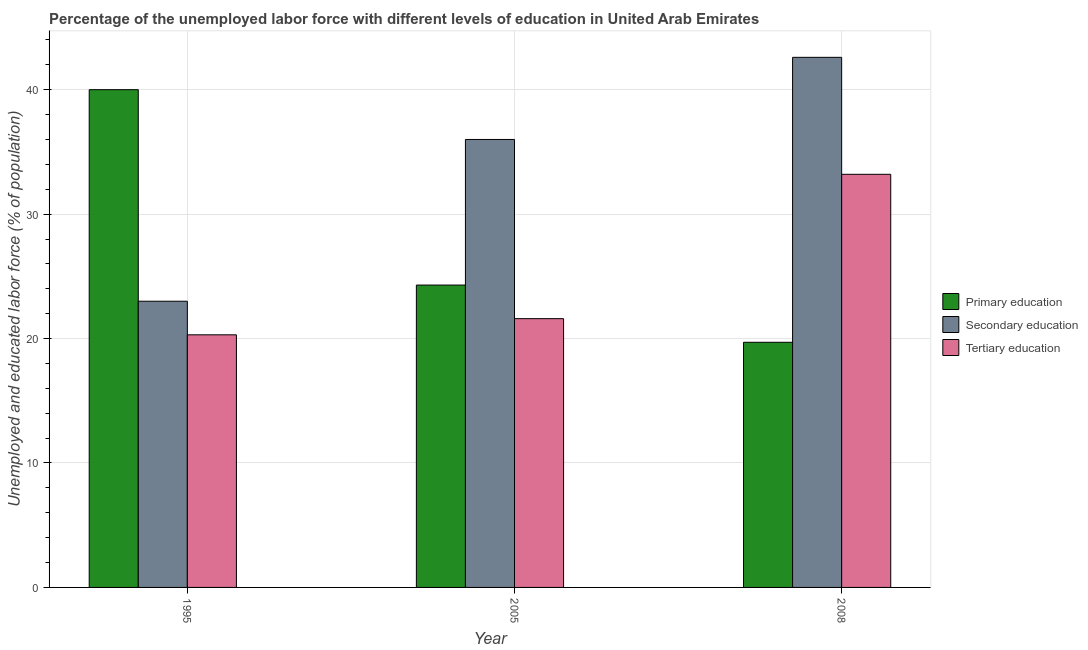Are the number of bars per tick equal to the number of legend labels?
Offer a very short reply. Yes. Are the number of bars on each tick of the X-axis equal?
Your answer should be compact. Yes. What is the label of the 1st group of bars from the left?
Provide a succinct answer. 1995. In how many cases, is the number of bars for a given year not equal to the number of legend labels?
Offer a terse response. 0. What is the percentage of labor force who received tertiary education in 2005?
Keep it short and to the point. 21.6. Across all years, what is the maximum percentage of labor force who received secondary education?
Provide a short and direct response. 42.6. In which year was the percentage of labor force who received tertiary education maximum?
Offer a terse response. 2008. In which year was the percentage of labor force who received tertiary education minimum?
Your answer should be compact. 1995. What is the difference between the percentage of labor force who received secondary education in 1995 and that in 2008?
Provide a short and direct response. -19.6. What is the difference between the percentage of labor force who received primary education in 2008 and the percentage of labor force who received secondary education in 1995?
Make the answer very short. -20.3. What is the average percentage of labor force who received primary education per year?
Keep it short and to the point. 28. In how many years, is the percentage of labor force who received tertiary education greater than 36 %?
Your answer should be very brief. 0. What is the ratio of the percentage of labor force who received secondary education in 1995 to that in 2005?
Ensure brevity in your answer.  0.64. Is the difference between the percentage of labor force who received tertiary education in 1995 and 2008 greater than the difference between the percentage of labor force who received secondary education in 1995 and 2008?
Ensure brevity in your answer.  No. What is the difference between the highest and the second highest percentage of labor force who received tertiary education?
Make the answer very short. 11.6. What is the difference between the highest and the lowest percentage of labor force who received tertiary education?
Offer a terse response. 12.9. What does the 2nd bar from the left in 2005 represents?
Offer a very short reply. Secondary education. What does the 1st bar from the right in 2005 represents?
Offer a very short reply. Tertiary education. Is it the case that in every year, the sum of the percentage of labor force who received primary education and percentage of labor force who received secondary education is greater than the percentage of labor force who received tertiary education?
Your response must be concise. Yes. Are all the bars in the graph horizontal?
Give a very brief answer. No. How many years are there in the graph?
Make the answer very short. 3. Are the values on the major ticks of Y-axis written in scientific E-notation?
Make the answer very short. No. Does the graph contain any zero values?
Provide a succinct answer. No. Does the graph contain grids?
Your answer should be compact. Yes. How many legend labels are there?
Offer a terse response. 3. How are the legend labels stacked?
Give a very brief answer. Vertical. What is the title of the graph?
Give a very brief answer. Percentage of the unemployed labor force with different levels of education in United Arab Emirates. Does "Coal sources" appear as one of the legend labels in the graph?
Ensure brevity in your answer.  No. What is the label or title of the Y-axis?
Make the answer very short. Unemployed and educated labor force (% of population). What is the Unemployed and educated labor force (% of population) of Primary education in 1995?
Give a very brief answer. 40. What is the Unemployed and educated labor force (% of population) of Tertiary education in 1995?
Your answer should be compact. 20.3. What is the Unemployed and educated labor force (% of population) in Primary education in 2005?
Provide a succinct answer. 24.3. What is the Unemployed and educated labor force (% of population) of Tertiary education in 2005?
Your answer should be compact. 21.6. What is the Unemployed and educated labor force (% of population) of Primary education in 2008?
Make the answer very short. 19.7. What is the Unemployed and educated labor force (% of population) of Secondary education in 2008?
Make the answer very short. 42.6. What is the Unemployed and educated labor force (% of population) in Tertiary education in 2008?
Your answer should be very brief. 33.2. Across all years, what is the maximum Unemployed and educated labor force (% of population) in Primary education?
Make the answer very short. 40. Across all years, what is the maximum Unemployed and educated labor force (% of population) of Secondary education?
Offer a terse response. 42.6. Across all years, what is the maximum Unemployed and educated labor force (% of population) of Tertiary education?
Offer a very short reply. 33.2. Across all years, what is the minimum Unemployed and educated labor force (% of population) in Primary education?
Give a very brief answer. 19.7. Across all years, what is the minimum Unemployed and educated labor force (% of population) of Tertiary education?
Offer a very short reply. 20.3. What is the total Unemployed and educated labor force (% of population) of Secondary education in the graph?
Offer a terse response. 101.6. What is the total Unemployed and educated labor force (% of population) in Tertiary education in the graph?
Offer a terse response. 75.1. What is the difference between the Unemployed and educated labor force (% of population) of Secondary education in 1995 and that in 2005?
Give a very brief answer. -13. What is the difference between the Unemployed and educated labor force (% of population) in Primary education in 1995 and that in 2008?
Ensure brevity in your answer.  20.3. What is the difference between the Unemployed and educated labor force (% of population) in Secondary education in 1995 and that in 2008?
Offer a very short reply. -19.6. What is the difference between the Unemployed and educated labor force (% of population) of Primary education in 2005 and that in 2008?
Offer a very short reply. 4.6. What is the difference between the Unemployed and educated labor force (% of population) of Tertiary education in 2005 and that in 2008?
Your response must be concise. -11.6. What is the difference between the Unemployed and educated labor force (% of population) of Primary education in 1995 and the Unemployed and educated labor force (% of population) of Secondary education in 2005?
Offer a terse response. 4. What is the difference between the Unemployed and educated labor force (% of population) of Primary education in 1995 and the Unemployed and educated labor force (% of population) of Tertiary education in 2005?
Give a very brief answer. 18.4. What is the difference between the Unemployed and educated labor force (% of population) in Primary education in 1995 and the Unemployed and educated labor force (% of population) in Tertiary education in 2008?
Ensure brevity in your answer.  6.8. What is the difference between the Unemployed and educated labor force (% of population) of Primary education in 2005 and the Unemployed and educated labor force (% of population) of Secondary education in 2008?
Give a very brief answer. -18.3. What is the difference between the Unemployed and educated labor force (% of population) in Primary education in 2005 and the Unemployed and educated labor force (% of population) in Tertiary education in 2008?
Keep it short and to the point. -8.9. What is the average Unemployed and educated labor force (% of population) of Secondary education per year?
Provide a short and direct response. 33.87. What is the average Unemployed and educated labor force (% of population) in Tertiary education per year?
Offer a very short reply. 25.03. In the year 1995, what is the difference between the Unemployed and educated labor force (% of population) of Primary education and Unemployed and educated labor force (% of population) of Secondary education?
Provide a succinct answer. 17. In the year 2005, what is the difference between the Unemployed and educated labor force (% of population) in Secondary education and Unemployed and educated labor force (% of population) in Tertiary education?
Keep it short and to the point. 14.4. In the year 2008, what is the difference between the Unemployed and educated labor force (% of population) of Primary education and Unemployed and educated labor force (% of population) of Secondary education?
Offer a terse response. -22.9. In the year 2008, what is the difference between the Unemployed and educated labor force (% of population) of Primary education and Unemployed and educated labor force (% of population) of Tertiary education?
Your response must be concise. -13.5. What is the ratio of the Unemployed and educated labor force (% of population) of Primary education in 1995 to that in 2005?
Provide a succinct answer. 1.65. What is the ratio of the Unemployed and educated labor force (% of population) in Secondary education in 1995 to that in 2005?
Keep it short and to the point. 0.64. What is the ratio of the Unemployed and educated labor force (% of population) in Tertiary education in 1995 to that in 2005?
Your response must be concise. 0.94. What is the ratio of the Unemployed and educated labor force (% of population) of Primary education in 1995 to that in 2008?
Your response must be concise. 2.03. What is the ratio of the Unemployed and educated labor force (% of population) in Secondary education in 1995 to that in 2008?
Keep it short and to the point. 0.54. What is the ratio of the Unemployed and educated labor force (% of population) in Tertiary education in 1995 to that in 2008?
Your answer should be compact. 0.61. What is the ratio of the Unemployed and educated labor force (% of population) of Primary education in 2005 to that in 2008?
Make the answer very short. 1.23. What is the ratio of the Unemployed and educated labor force (% of population) of Secondary education in 2005 to that in 2008?
Your answer should be compact. 0.85. What is the ratio of the Unemployed and educated labor force (% of population) of Tertiary education in 2005 to that in 2008?
Provide a succinct answer. 0.65. What is the difference between the highest and the second highest Unemployed and educated labor force (% of population) of Primary education?
Your response must be concise. 15.7. What is the difference between the highest and the lowest Unemployed and educated labor force (% of population) of Primary education?
Make the answer very short. 20.3. What is the difference between the highest and the lowest Unemployed and educated labor force (% of population) in Secondary education?
Make the answer very short. 19.6. What is the difference between the highest and the lowest Unemployed and educated labor force (% of population) in Tertiary education?
Make the answer very short. 12.9. 